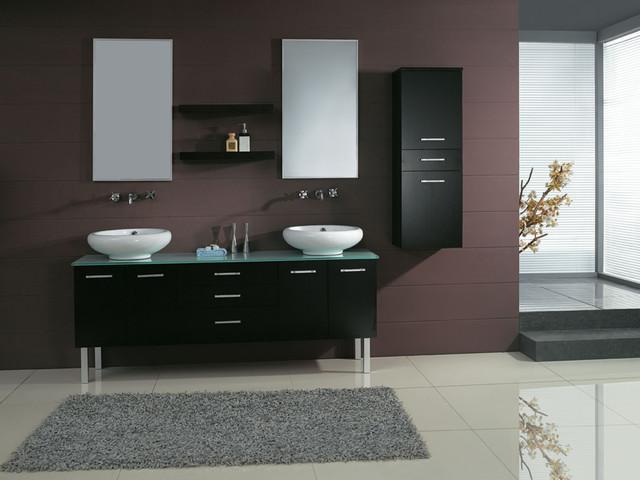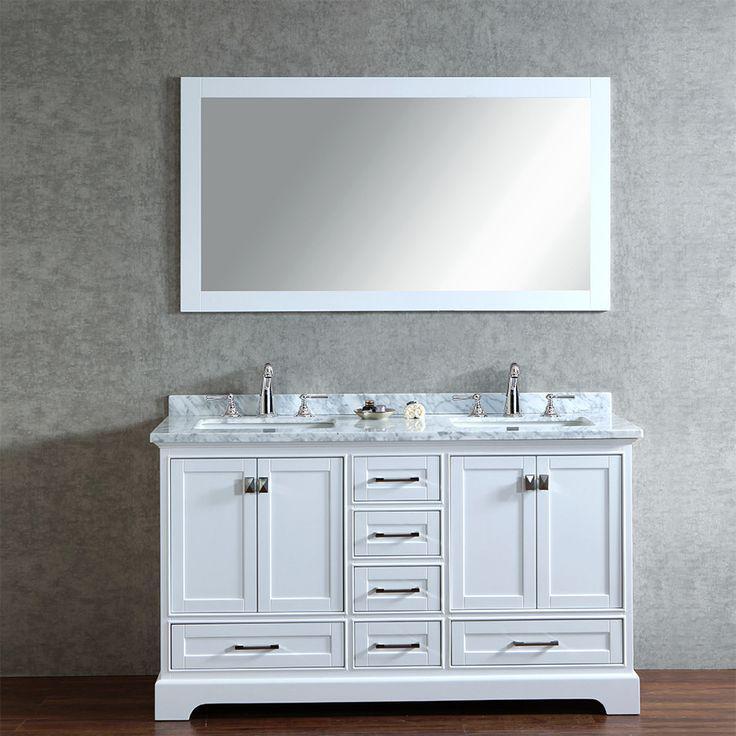The first image is the image on the left, the second image is the image on the right. Analyze the images presented: Is the assertion "One picture has mirrors with black borders" valid? Answer yes or no. No. 